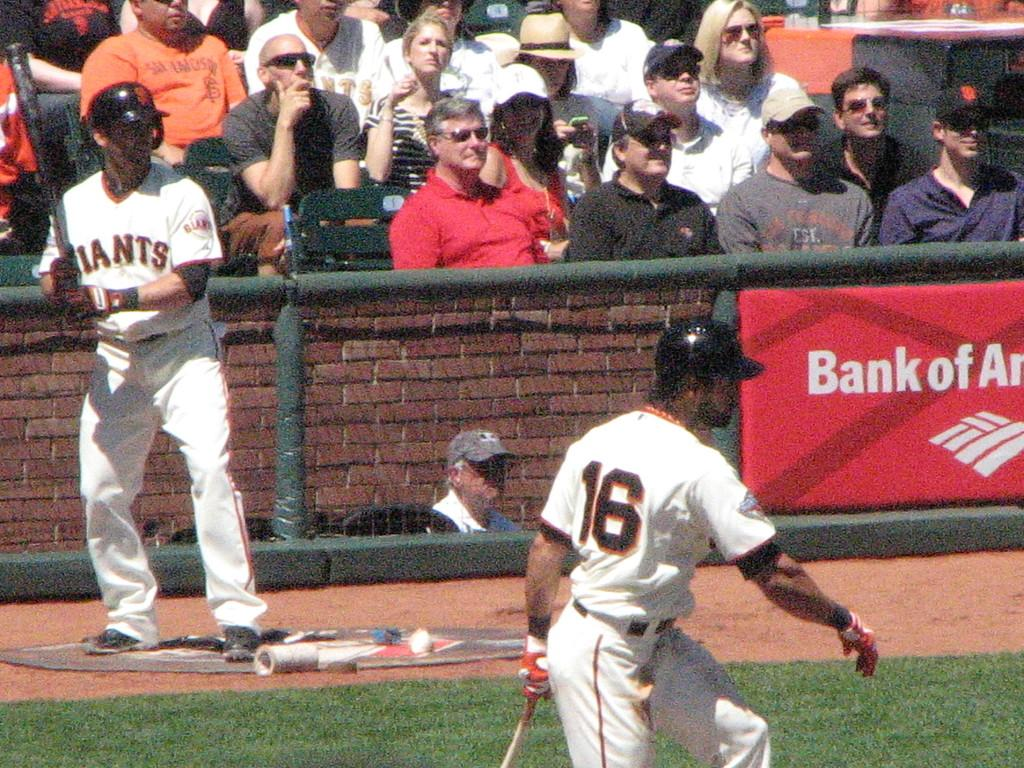How many baseball players are in the image? There are two baseball players in the image. What is the color of the grass in the image? The grass in the image is green. What can be seen in the background of the image? There are spectators in the background of the image. What is the large sign in the image called? The large sign in the image is called a hoarding. How many tomatoes are being thrown by the cats in the image? There are no tomatoes or cats present in the image. What type of agreement do the baseball players have in the image? The image does not show any agreements between the baseball players; it only depicts them playing baseball. 